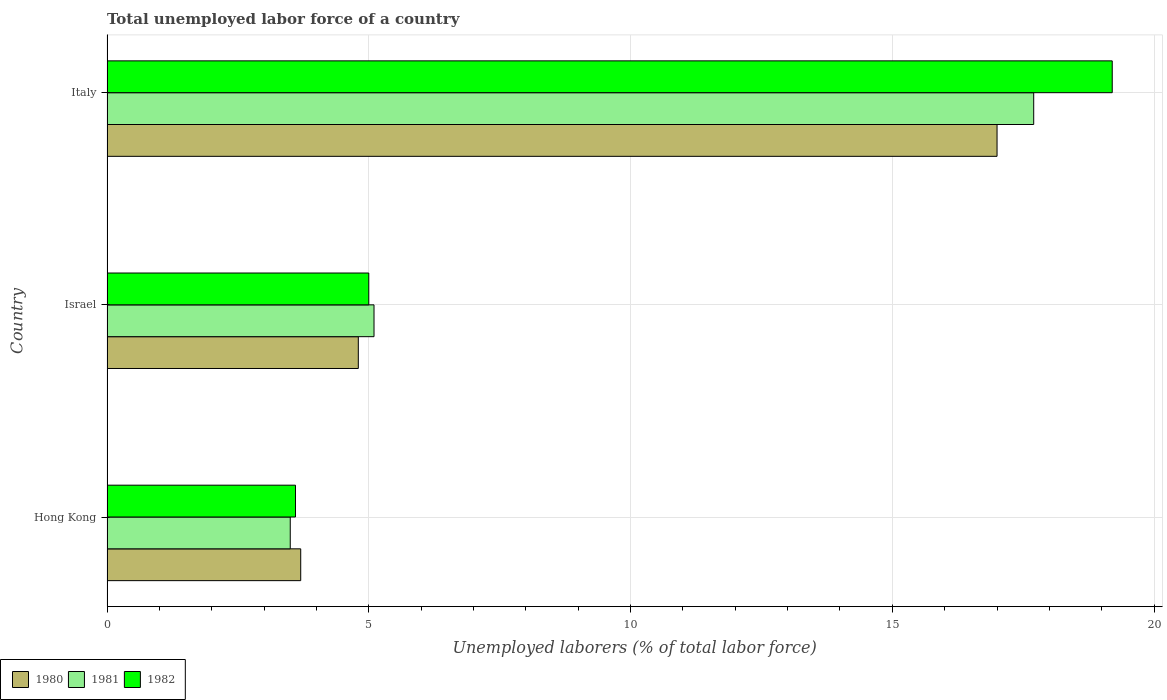How many bars are there on the 2nd tick from the top?
Keep it short and to the point. 3. What is the label of the 1st group of bars from the top?
Give a very brief answer. Italy. In how many cases, is the number of bars for a given country not equal to the number of legend labels?
Your response must be concise. 0. What is the total unemployed labor force in 1980 in Hong Kong?
Provide a succinct answer. 3.7. Across all countries, what is the maximum total unemployed labor force in 1981?
Offer a very short reply. 17.7. Across all countries, what is the minimum total unemployed labor force in 1980?
Keep it short and to the point. 3.7. In which country was the total unemployed labor force in 1981 maximum?
Provide a short and direct response. Italy. In which country was the total unemployed labor force in 1980 minimum?
Your response must be concise. Hong Kong. What is the total total unemployed labor force in 1982 in the graph?
Give a very brief answer. 27.8. What is the difference between the total unemployed labor force in 1981 in Hong Kong and that in Israel?
Make the answer very short. -1.6. What is the difference between the total unemployed labor force in 1982 in Israel and the total unemployed labor force in 1980 in Italy?
Offer a terse response. -12. What is the average total unemployed labor force in 1982 per country?
Your answer should be compact. 9.27. What is the difference between the total unemployed labor force in 1982 and total unemployed labor force in 1981 in Hong Kong?
Your response must be concise. 0.1. In how many countries, is the total unemployed labor force in 1982 greater than 15 %?
Your answer should be compact. 1. What is the ratio of the total unemployed labor force in 1981 in Hong Kong to that in Israel?
Your answer should be compact. 0.69. Is the difference between the total unemployed labor force in 1982 in Hong Kong and Italy greater than the difference between the total unemployed labor force in 1981 in Hong Kong and Italy?
Offer a terse response. No. What is the difference between the highest and the second highest total unemployed labor force in 1982?
Offer a very short reply. 14.2. What is the difference between the highest and the lowest total unemployed labor force in 1981?
Make the answer very short. 14.2. In how many countries, is the total unemployed labor force in 1982 greater than the average total unemployed labor force in 1982 taken over all countries?
Offer a terse response. 1. What does the 2nd bar from the top in Israel represents?
Provide a short and direct response. 1981. What does the 1st bar from the bottom in Hong Kong represents?
Give a very brief answer. 1980. Is it the case that in every country, the sum of the total unemployed labor force in 1980 and total unemployed labor force in 1981 is greater than the total unemployed labor force in 1982?
Your response must be concise. Yes. How many bars are there?
Your answer should be very brief. 9. What is the difference between two consecutive major ticks on the X-axis?
Your answer should be very brief. 5. Does the graph contain any zero values?
Keep it short and to the point. No. How many legend labels are there?
Your answer should be compact. 3. How are the legend labels stacked?
Your answer should be compact. Horizontal. What is the title of the graph?
Offer a terse response. Total unemployed labor force of a country. What is the label or title of the X-axis?
Your answer should be very brief. Unemployed laborers (% of total labor force). What is the label or title of the Y-axis?
Your response must be concise. Country. What is the Unemployed laborers (% of total labor force) in 1980 in Hong Kong?
Provide a short and direct response. 3.7. What is the Unemployed laborers (% of total labor force) of 1981 in Hong Kong?
Offer a very short reply. 3.5. What is the Unemployed laborers (% of total labor force) in 1982 in Hong Kong?
Offer a terse response. 3.6. What is the Unemployed laborers (% of total labor force) in 1980 in Israel?
Offer a terse response. 4.8. What is the Unemployed laborers (% of total labor force) in 1981 in Israel?
Make the answer very short. 5.1. What is the Unemployed laborers (% of total labor force) of 1980 in Italy?
Your answer should be very brief. 17. What is the Unemployed laborers (% of total labor force) in 1981 in Italy?
Offer a very short reply. 17.7. What is the Unemployed laborers (% of total labor force) in 1982 in Italy?
Your answer should be compact. 19.2. Across all countries, what is the maximum Unemployed laborers (% of total labor force) in 1980?
Give a very brief answer. 17. Across all countries, what is the maximum Unemployed laborers (% of total labor force) of 1981?
Provide a short and direct response. 17.7. Across all countries, what is the maximum Unemployed laborers (% of total labor force) of 1982?
Give a very brief answer. 19.2. Across all countries, what is the minimum Unemployed laborers (% of total labor force) in 1980?
Provide a short and direct response. 3.7. Across all countries, what is the minimum Unemployed laborers (% of total labor force) of 1982?
Your response must be concise. 3.6. What is the total Unemployed laborers (% of total labor force) in 1980 in the graph?
Your answer should be compact. 25.5. What is the total Unemployed laborers (% of total labor force) of 1981 in the graph?
Give a very brief answer. 26.3. What is the total Unemployed laborers (% of total labor force) in 1982 in the graph?
Make the answer very short. 27.8. What is the difference between the Unemployed laborers (% of total labor force) of 1980 in Hong Kong and that in Israel?
Keep it short and to the point. -1.1. What is the difference between the Unemployed laborers (% of total labor force) of 1981 in Hong Kong and that in Israel?
Keep it short and to the point. -1.6. What is the difference between the Unemployed laborers (% of total labor force) of 1980 in Hong Kong and that in Italy?
Give a very brief answer. -13.3. What is the difference between the Unemployed laborers (% of total labor force) of 1981 in Hong Kong and that in Italy?
Ensure brevity in your answer.  -14.2. What is the difference between the Unemployed laborers (% of total labor force) in 1982 in Hong Kong and that in Italy?
Your answer should be compact. -15.6. What is the difference between the Unemployed laborers (% of total labor force) of 1981 in Israel and that in Italy?
Make the answer very short. -12.6. What is the difference between the Unemployed laborers (% of total labor force) of 1980 in Hong Kong and the Unemployed laborers (% of total labor force) of 1981 in Israel?
Ensure brevity in your answer.  -1.4. What is the difference between the Unemployed laborers (% of total labor force) in 1980 in Hong Kong and the Unemployed laborers (% of total labor force) in 1982 in Italy?
Offer a terse response. -15.5. What is the difference between the Unemployed laborers (% of total labor force) of 1981 in Hong Kong and the Unemployed laborers (% of total labor force) of 1982 in Italy?
Offer a terse response. -15.7. What is the difference between the Unemployed laborers (% of total labor force) of 1980 in Israel and the Unemployed laborers (% of total labor force) of 1982 in Italy?
Give a very brief answer. -14.4. What is the difference between the Unemployed laborers (% of total labor force) of 1981 in Israel and the Unemployed laborers (% of total labor force) of 1982 in Italy?
Your response must be concise. -14.1. What is the average Unemployed laborers (% of total labor force) in 1981 per country?
Offer a terse response. 8.77. What is the average Unemployed laborers (% of total labor force) in 1982 per country?
Offer a very short reply. 9.27. What is the difference between the Unemployed laborers (% of total labor force) in 1980 and Unemployed laborers (% of total labor force) in 1981 in Hong Kong?
Ensure brevity in your answer.  0.2. What is the difference between the Unemployed laborers (% of total labor force) in 1980 and Unemployed laborers (% of total labor force) in 1982 in Hong Kong?
Your answer should be compact. 0.1. What is the difference between the Unemployed laborers (% of total labor force) in 1981 and Unemployed laborers (% of total labor force) in 1982 in Hong Kong?
Give a very brief answer. -0.1. What is the difference between the Unemployed laborers (% of total labor force) in 1981 and Unemployed laborers (% of total labor force) in 1982 in Israel?
Your answer should be very brief. 0.1. What is the difference between the Unemployed laborers (% of total labor force) in 1980 and Unemployed laborers (% of total labor force) in 1981 in Italy?
Make the answer very short. -0.7. What is the difference between the Unemployed laborers (% of total labor force) of 1980 and Unemployed laborers (% of total labor force) of 1982 in Italy?
Provide a short and direct response. -2.2. What is the ratio of the Unemployed laborers (% of total labor force) of 1980 in Hong Kong to that in Israel?
Offer a terse response. 0.77. What is the ratio of the Unemployed laborers (% of total labor force) in 1981 in Hong Kong to that in Israel?
Offer a very short reply. 0.69. What is the ratio of the Unemployed laborers (% of total labor force) in 1982 in Hong Kong to that in Israel?
Provide a succinct answer. 0.72. What is the ratio of the Unemployed laborers (% of total labor force) in 1980 in Hong Kong to that in Italy?
Your answer should be compact. 0.22. What is the ratio of the Unemployed laborers (% of total labor force) of 1981 in Hong Kong to that in Italy?
Your answer should be compact. 0.2. What is the ratio of the Unemployed laborers (% of total labor force) in 1982 in Hong Kong to that in Italy?
Provide a short and direct response. 0.19. What is the ratio of the Unemployed laborers (% of total labor force) of 1980 in Israel to that in Italy?
Ensure brevity in your answer.  0.28. What is the ratio of the Unemployed laborers (% of total labor force) in 1981 in Israel to that in Italy?
Make the answer very short. 0.29. What is the ratio of the Unemployed laborers (% of total labor force) in 1982 in Israel to that in Italy?
Make the answer very short. 0.26. What is the difference between the highest and the second highest Unemployed laborers (% of total labor force) in 1981?
Your answer should be compact. 12.6. What is the difference between the highest and the lowest Unemployed laborers (% of total labor force) of 1981?
Your answer should be very brief. 14.2. What is the difference between the highest and the lowest Unemployed laborers (% of total labor force) in 1982?
Give a very brief answer. 15.6. 